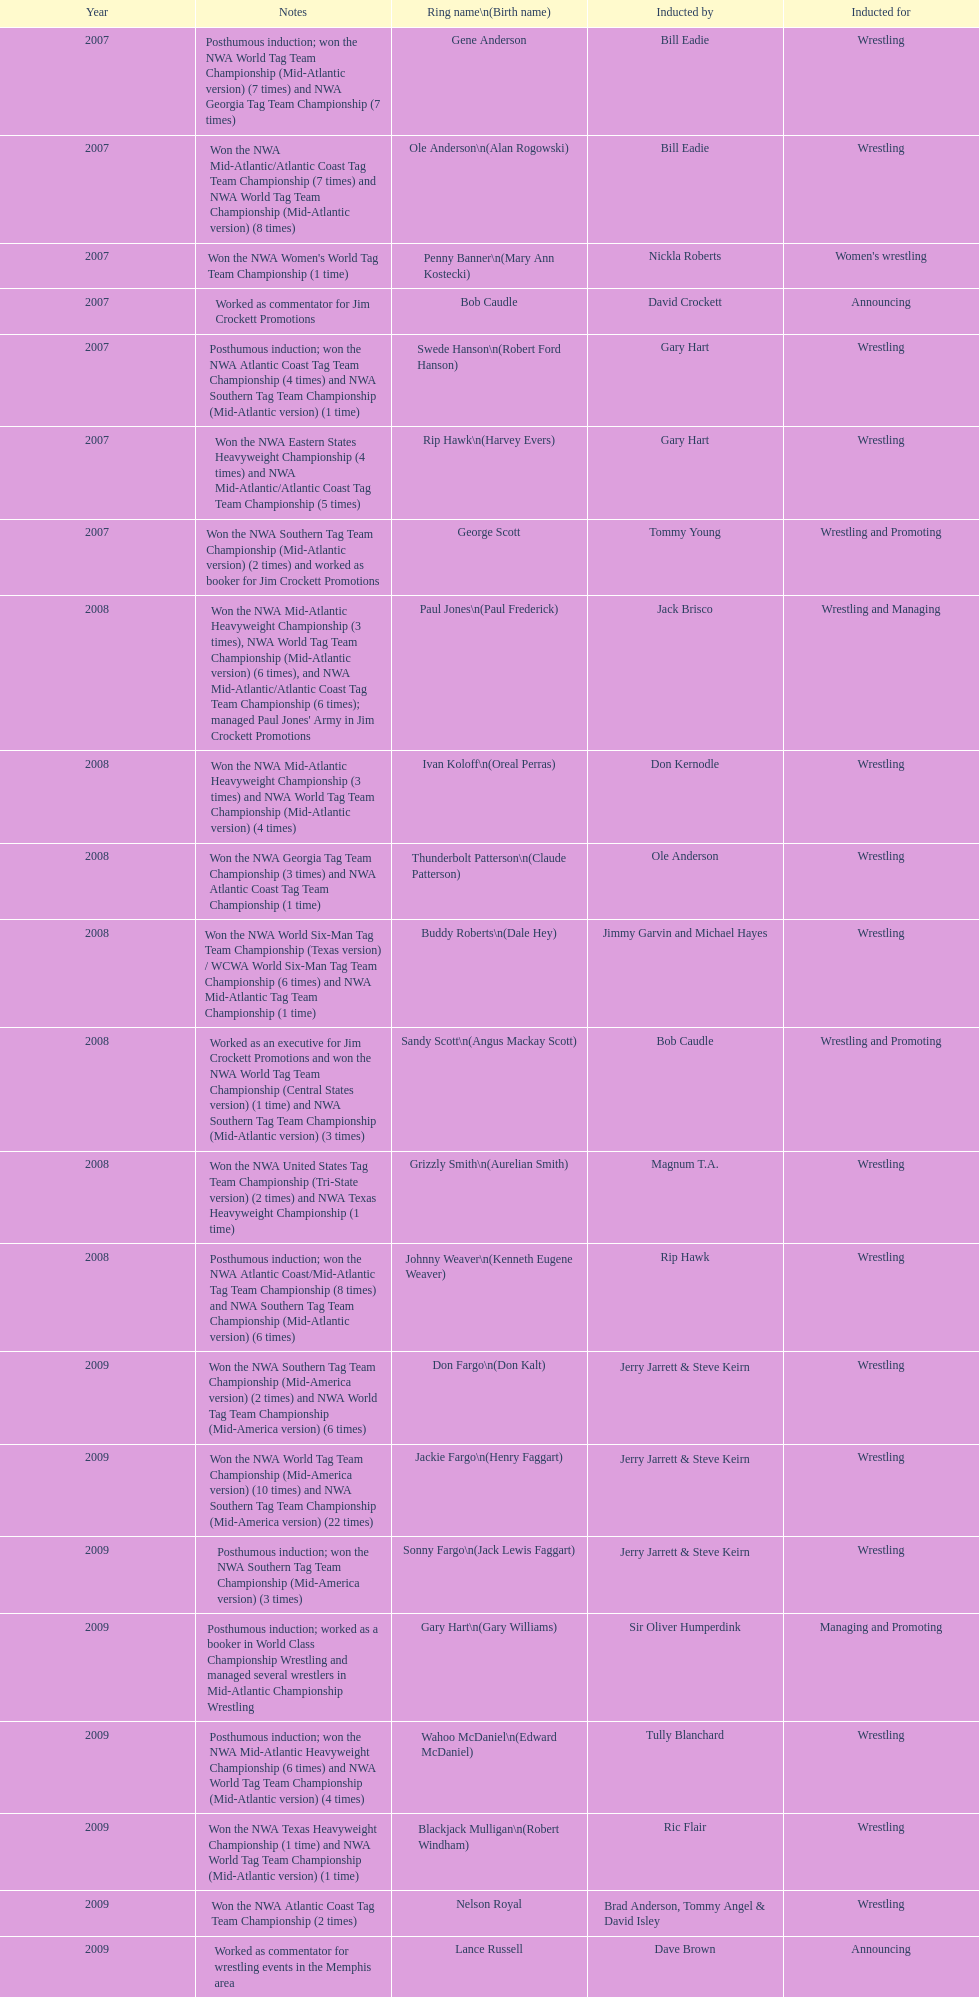Who was the announcer inducted into the hall of heroes in 2007? Bob Caudle. Who was the next announcer to be inducted? Lance Russell. 